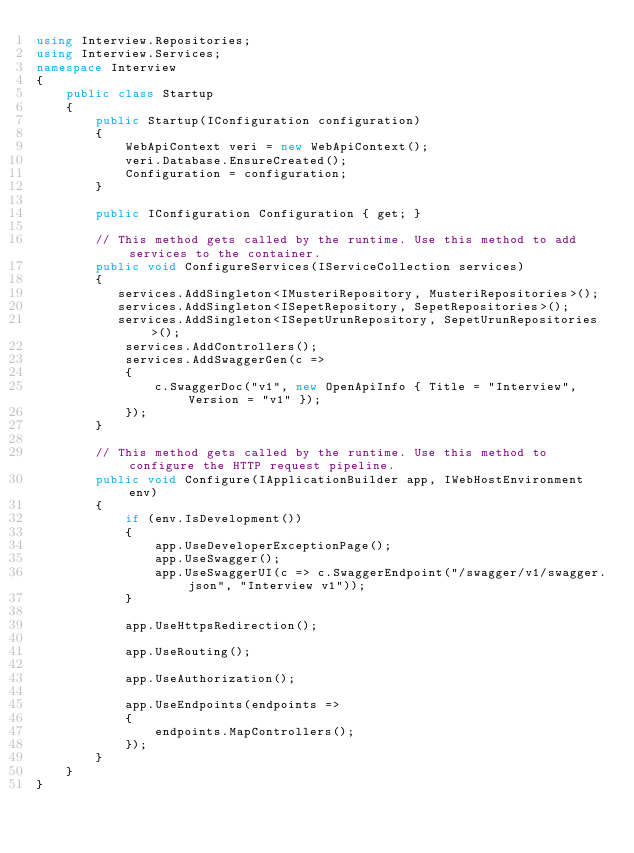<code> <loc_0><loc_0><loc_500><loc_500><_C#_>using Interview.Repositories;
using Interview.Services;
namespace Interview
{
    public class Startup
    {
        public Startup(IConfiguration configuration)
        {
            WebApiContext veri = new WebApiContext();
            veri.Database.EnsureCreated();
            Configuration = configuration;
        }

        public IConfiguration Configuration { get; }

        // This method gets called by the runtime. Use this method to add services to the container.
        public void ConfigureServices(IServiceCollection services)
        {
           services.AddSingleton<IMusteriRepository, MusteriRepositories>();
           services.AddSingleton<ISepetRepository, SepetRepositories>();
           services.AddSingleton<ISepetUrunRepository, SepetUrunRepositories>();
            services.AddControllers();
            services.AddSwaggerGen(c =>
            {
                c.SwaggerDoc("v1", new OpenApiInfo { Title = "Interview", Version = "v1" });
            });
        }

        // This method gets called by the runtime. Use this method to configure the HTTP request pipeline.
        public void Configure(IApplicationBuilder app, IWebHostEnvironment env)
        {
            if (env.IsDevelopment())
            {
                app.UseDeveloperExceptionPage();
                app.UseSwagger();
                app.UseSwaggerUI(c => c.SwaggerEndpoint("/swagger/v1/swagger.json", "Interview v1"));
            }

            app.UseHttpsRedirection();

            app.UseRouting();

            app.UseAuthorization();

            app.UseEndpoints(endpoints =>
            {
                endpoints.MapControllers();
            });
        }
    }
}
</code> 